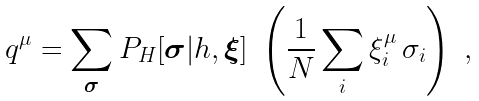Convert formula to latex. <formula><loc_0><loc_0><loc_500><loc_500>q ^ { \mu } = \sum _ { \boldsymbol \sigma } P _ { H } [ \boldsymbol \sigma | { h } , \boldsymbol \xi ] \ \left ( \frac { 1 } { N } \sum _ { i } \xi _ { i } ^ { \mu } \, \sigma _ { i } \right ) \ ,</formula> 